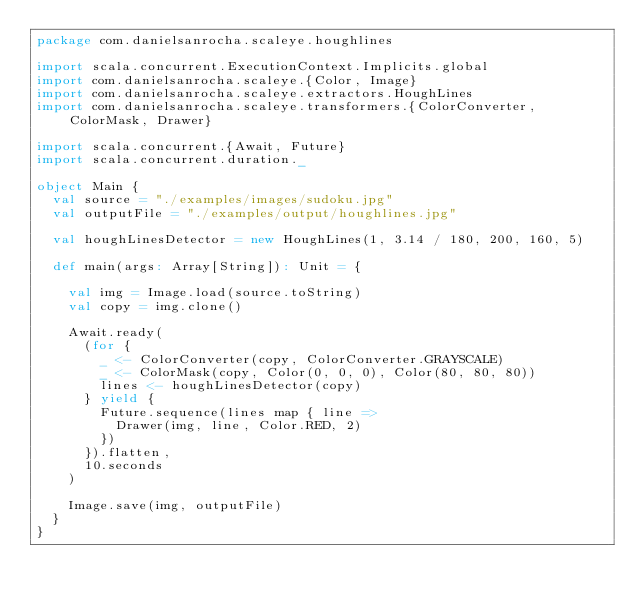Convert code to text. <code><loc_0><loc_0><loc_500><loc_500><_Scala_>package com.danielsanrocha.scaleye.houghlines

import scala.concurrent.ExecutionContext.Implicits.global
import com.danielsanrocha.scaleye.{Color, Image}
import com.danielsanrocha.scaleye.extractors.HoughLines
import com.danielsanrocha.scaleye.transformers.{ColorConverter, ColorMask, Drawer}

import scala.concurrent.{Await, Future}
import scala.concurrent.duration._

object Main {
  val source = "./examples/images/sudoku.jpg"
  val outputFile = "./examples/output/houghlines.jpg"

  val houghLinesDetector = new HoughLines(1, 3.14 / 180, 200, 160, 5)

  def main(args: Array[String]): Unit = {

    val img = Image.load(source.toString)
    val copy = img.clone()

    Await.ready(
      (for {
        _ <- ColorConverter(copy, ColorConverter.GRAYSCALE)
        _ <- ColorMask(copy, Color(0, 0, 0), Color(80, 80, 80))
        lines <- houghLinesDetector(copy)
      } yield {
        Future.sequence(lines map { line =>
          Drawer(img, line, Color.RED, 2)
        })
      }).flatten,
      10.seconds
    )

    Image.save(img, outputFile)
  }
}
</code> 